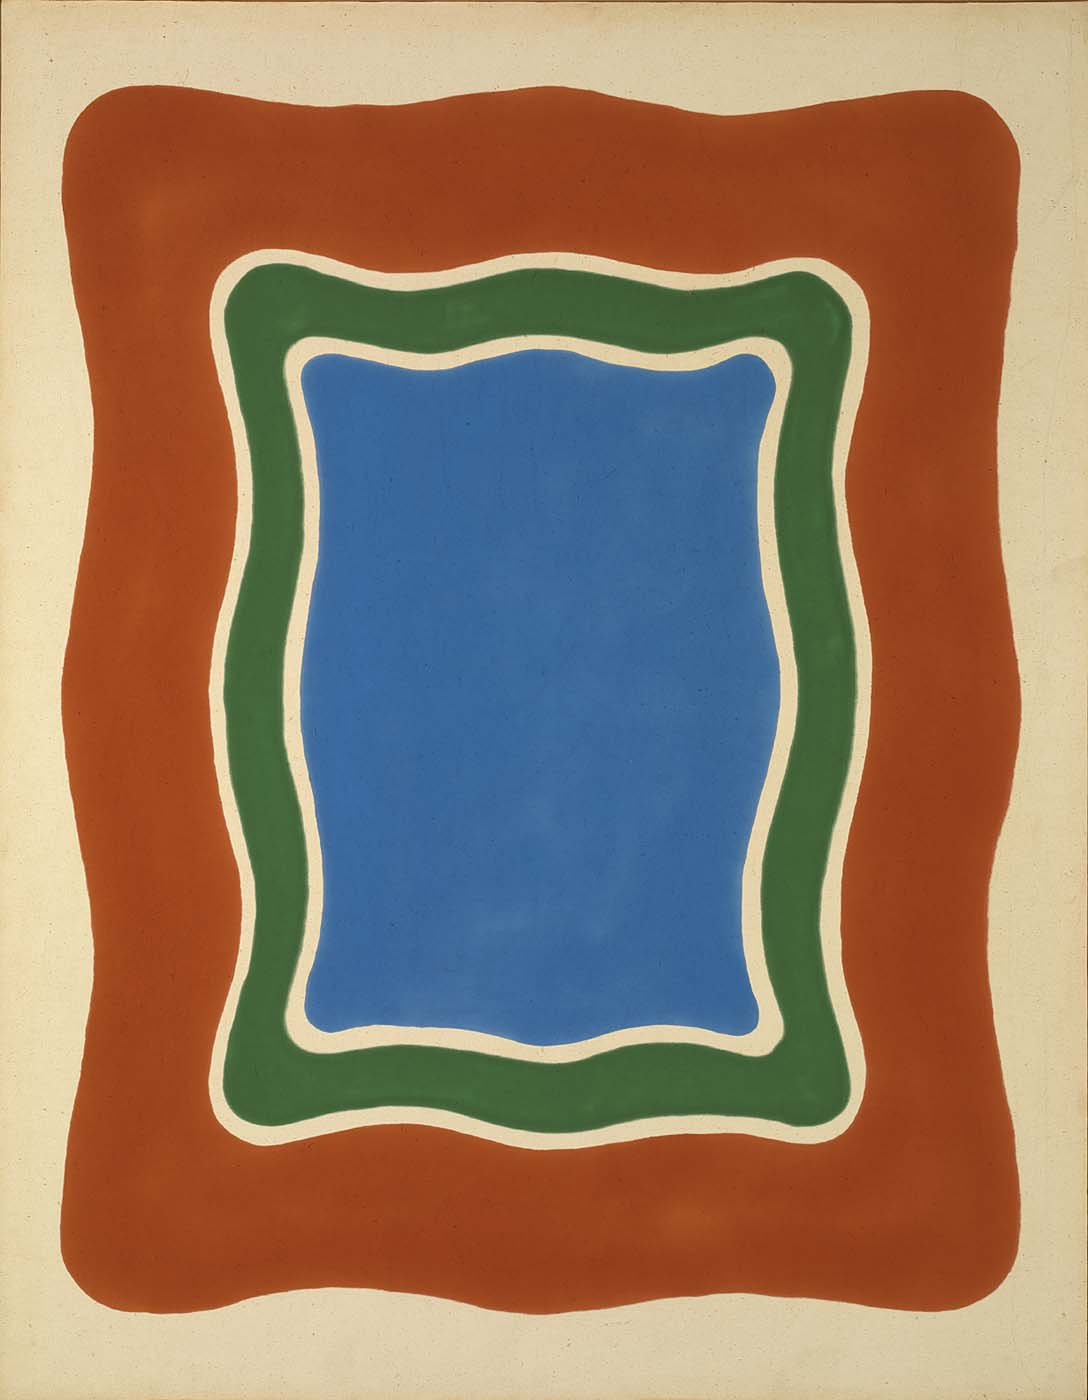How would you relate this artwork to nature? This artwork can be seen as a representation of natural landscapes. The blue rectangle may symbolize a serene lake or clear sky, the green border evoking lush forests or fields, and the red encompassing the rich, life-giving earth. The curvy lines suggest the organic and fluid forms found in nature, such as rolling hills, meandering rivers, or the contours of natural formations. This connection to nature highlights the artwork’s reflection on the inherent beauty and balance found in the natural world. 